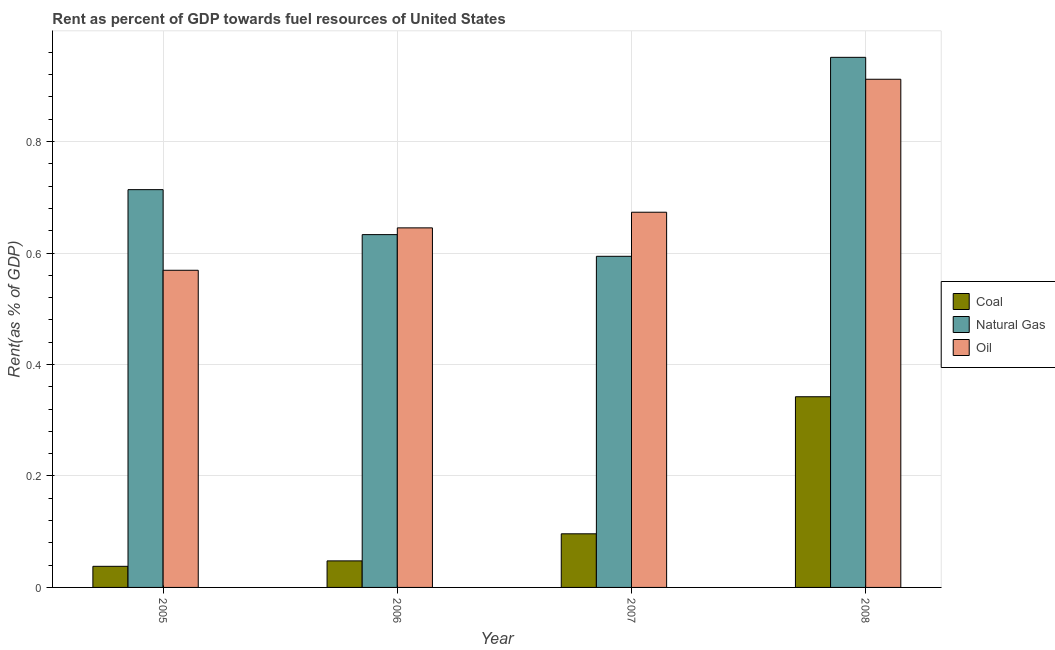Are the number of bars on each tick of the X-axis equal?
Make the answer very short. Yes. How many bars are there on the 1st tick from the left?
Give a very brief answer. 3. In how many cases, is the number of bars for a given year not equal to the number of legend labels?
Your answer should be compact. 0. What is the rent towards natural gas in 2007?
Your answer should be very brief. 0.59. Across all years, what is the maximum rent towards natural gas?
Ensure brevity in your answer.  0.95. Across all years, what is the minimum rent towards natural gas?
Provide a succinct answer. 0.59. In which year was the rent towards natural gas maximum?
Ensure brevity in your answer.  2008. What is the total rent towards natural gas in the graph?
Offer a terse response. 2.89. What is the difference between the rent towards coal in 2006 and that in 2007?
Ensure brevity in your answer.  -0.05. What is the difference between the rent towards oil in 2007 and the rent towards coal in 2006?
Your answer should be compact. 0.03. What is the average rent towards coal per year?
Your response must be concise. 0.13. In how many years, is the rent towards natural gas greater than 0.68 %?
Your response must be concise. 2. What is the ratio of the rent towards oil in 2005 to that in 2006?
Your answer should be compact. 0.88. What is the difference between the highest and the second highest rent towards coal?
Provide a short and direct response. 0.25. What is the difference between the highest and the lowest rent towards natural gas?
Provide a succinct answer. 0.36. In how many years, is the rent towards coal greater than the average rent towards coal taken over all years?
Your answer should be very brief. 1. Is the sum of the rent towards oil in 2005 and 2007 greater than the maximum rent towards natural gas across all years?
Your answer should be compact. Yes. What does the 1st bar from the left in 2006 represents?
Offer a very short reply. Coal. What does the 1st bar from the right in 2006 represents?
Your response must be concise. Oil. How many bars are there?
Provide a succinct answer. 12. Are all the bars in the graph horizontal?
Make the answer very short. No. What is the difference between two consecutive major ticks on the Y-axis?
Make the answer very short. 0.2. How are the legend labels stacked?
Keep it short and to the point. Vertical. What is the title of the graph?
Give a very brief answer. Rent as percent of GDP towards fuel resources of United States. Does "Social Protection" appear as one of the legend labels in the graph?
Your answer should be very brief. No. What is the label or title of the Y-axis?
Provide a succinct answer. Rent(as % of GDP). What is the Rent(as % of GDP) in Coal in 2005?
Your response must be concise. 0.04. What is the Rent(as % of GDP) of Natural Gas in 2005?
Your response must be concise. 0.71. What is the Rent(as % of GDP) in Oil in 2005?
Ensure brevity in your answer.  0.57. What is the Rent(as % of GDP) in Coal in 2006?
Make the answer very short. 0.05. What is the Rent(as % of GDP) in Natural Gas in 2006?
Your response must be concise. 0.63. What is the Rent(as % of GDP) of Oil in 2006?
Make the answer very short. 0.65. What is the Rent(as % of GDP) of Coal in 2007?
Make the answer very short. 0.1. What is the Rent(as % of GDP) in Natural Gas in 2007?
Offer a very short reply. 0.59. What is the Rent(as % of GDP) in Oil in 2007?
Provide a short and direct response. 0.67. What is the Rent(as % of GDP) in Coal in 2008?
Offer a very short reply. 0.34. What is the Rent(as % of GDP) of Natural Gas in 2008?
Your response must be concise. 0.95. What is the Rent(as % of GDP) in Oil in 2008?
Ensure brevity in your answer.  0.91. Across all years, what is the maximum Rent(as % of GDP) of Coal?
Offer a very short reply. 0.34. Across all years, what is the maximum Rent(as % of GDP) of Natural Gas?
Your answer should be very brief. 0.95. Across all years, what is the maximum Rent(as % of GDP) of Oil?
Your response must be concise. 0.91. Across all years, what is the minimum Rent(as % of GDP) in Coal?
Offer a terse response. 0.04. Across all years, what is the minimum Rent(as % of GDP) in Natural Gas?
Your answer should be compact. 0.59. Across all years, what is the minimum Rent(as % of GDP) of Oil?
Offer a very short reply. 0.57. What is the total Rent(as % of GDP) of Coal in the graph?
Your answer should be compact. 0.52. What is the total Rent(as % of GDP) in Natural Gas in the graph?
Keep it short and to the point. 2.89. What is the total Rent(as % of GDP) in Oil in the graph?
Provide a short and direct response. 2.8. What is the difference between the Rent(as % of GDP) of Coal in 2005 and that in 2006?
Offer a terse response. -0.01. What is the difference between the Rent(as % of GDP) of Natural Gas in 2005 and that in 2006?
Your answer should be very brief. 0.08. What is the difference between the Rent(as % of GDP) of Oil in 2005 and that in 2006?
Ensure brevity in your answer.  -0.08. What is the difference between the Rent(as % of GDP) in Coal in 2005 and that in 2007?
Give a very brief answer. -0.06. What is the difference between the Rent(as % of GDP) of Natural Gas in 2005 and that in 2007?
Make the answer very short. 0.12. What is the difference between the Rent(as % of GDP) of Oil in 2005 and that in 2007?
Make the answer very short. -0.1. What is the difference between the Rent(as % of GDP) of Coal in 2005 and that in 2008?
Your answer should be compact. -0.3. What is the difference between the Rent(as % of GDP) of Natural Gas in 2005 and that in 2008?
Your answer should be very brief. -0.24. What is the difference between the Rent(as % of GDP) in Oil in 2005 and that in 2008?
Offer a terse response. -0.34. What is the difference between the Rent(as % of GDP) of Coal in 2006 and that in 2007?
Make the answer very short. -0.05. What is the difference between the Rent(as % of GDP) in Natural Gas in 2006 and that in 2007?
Keep it short and to the point. 0.04. What is the difference between the Rent(as % of GDP) of Oil in 2006 and that in 2007?
Provide a succinct answer. -0.03. What is the difference between the Rent(as % of GDP) of Coal in 2006 and that in 2008?
Provide a succinct answer. -0.29. What is the difference between the Rent(as % of GDP) of Natural Gas in 2006 and that in 2008?
Offer a terse response. -0.32. What is the difference between the Rent(as % of GDP) of Oil in 2006 and that in 2008?
Your answer should be compact. -0.27. What is the difference between the Rent(as % of GDP) of Coal in 2007 and that in 2008?
Offer a very short reply. -0.25. What is the difference between the Rent(as % of GDP) of Natural Gas in 2007 and that in 2008?
Your answer should be very brief. -0.36. What is the difference between the Rent(as % of GDP) in Oil in 2007 and that in 2008?
Keep it short and to the point. -0.24. What is the difference between the Rent(as % of GDP) of Coal in 2005 and the Rent(as % of GDP) of Natural Gas in 2006?
Offer a terse response. -0.6. What is the difference between the Rent(as % of GDP) in Coal in 2005 and the Rent(as % of GDP) in Oil in 2006?
Provide a succinct answer. -0.61. What is the difference between the Rent(as % of GDP) in Natural Gas in 2005 and the Rent(as % of GDP) in Oil in 2006?
Keep it short and to the point. 0.07. What is the difference between the Rent(as % of GDP) of Coal in 2005 and the Rent(as % of GDP) of Natural Gas in 2007?
Ensure brevity in your answer.  -0.56. What is the difference between the Rent(as % of GDP) in Coal in 2005 and the Rent(as % of GDP) in Oil in 2007?
Offer a very short reply. -0.64. What is the difference between the Rent(as % of GDP) of Natural Gas in 2005 and the Rent(as % of GDP) of Oil in 2007?
Your answer should be compact. 0.04. What is the difference between the Rent(as % of GDP) in Coal in 2005 and the Rent(as % of GDP) in Natural Gas in 2008?
Ensure brevity in your answer.  -0.91. What is the difference between the Rent(as % of GDP) of Coal in 2005 and the Rent(as % of GDP) of Oil in 2008?
Your answer should be compact. -0.87. What is the difference between the Rent(as % of GDP) in Natural Gas in 2005 and the Rent(as % of GDP) in Oil in 2008?
Make the answer very short. -0.2. What is the difference between the Rent(as % of GDP) of Coal in 2006 and the Rent(as % of GDP) of Natural Gas in 2007?
Your answer should be compact. -0.55. What is the difference between the Rent(as % of GDP) in Coal in 2006 and the Rent(as % of GDP) in Oil in 2007?
Your answer should be compact. -0.63. What is the difference between the Rent(as % of GDP) of Natural Gas in 2006 and the Rent(as % of GDP) of Oil in 2007?
Give a very brief answer. -0.04. What is the difference between the Rent(as % of GDP) in Coal in 2006 and the Rent(as % of GDP) in Natural Gas in 2008?
Your answer should be compact. -0.9. What is the difference between the Rent(as % of GDP) of Coal in 2006 and the Rent(as % of GDP) of Oil in 2008?
Make the answer very short. -0.86. What is the difference between the Rent(as % of GDP) of Natural Gas in 2006 and the Rent(as % of GDP) of Oil in 2008?
Offer a very short reply. -0.28. What is the difference between the Rent(as % of GDP) of Coal in 2007 and the Rent(as % of GDP) of Natural Gas in 2008?
Give a very brief answer. -0.85. What is the difference between the Rent(as % of GDP) of Coal in 2007 and the Rent(as % of GDP) of Oil in 2008?
Your answer should be very brief. -0.82. What is the difference between the Rent(as % of GDP) of Natural Gas in 2007 and the Rent(as % of GDP) of Oil in 2008?
Your answer should be very brief. -0.32. What is the average Rent(as % of GDP) in Coal per year?
Keep it short and to the point. 0.13. What is the average Rent(as % of GDP) of Natural Gas per year?
Make the answer very short. 0.72. What is the average Rent(as % of GDP) of Oil per year?
Provide a short and direct response. 0.7. In the year 2005, what is the difference between the Rent(as % of GDP) of Coal and Rent(as % of GDP) of Natural Gas?
Provide a succinct answer. -0.68. In the year 2005, what is the difference between the Rent(as % of GDP) in Coal and Rent(as % of GDP) in Oil?
Provide a short and direct response. -0.53. In the year 2005, what is the difference between the Rent(as % of GDP) of Natural Gas and Rent(as % of GDP) of Oil?
Your answer should be compact. 0.14. In the year 2006, what is the difference between the Rent(as % of GDP) of Coal and Rent(as % of GDP) of Natural Gas?
Ensure brevity in your answer.  -0.59. In the year 2006, what is the difference between the Rent(as % of GDP) of Coal and Rent(as % of GDP) of Oil?
Your answer should be compact. -0.6. In the year 2006, what is the difference between the Rent(as % of GDP) in Natural Gas and Rent(as % of GDP) in Oil?
Keep it short and to the point. -0.01. In the year 2007, what is the difference between the Rent(as % of GDP) of Coal and Rent(as % of GDP) of Natural Gas?
Ensure brevity in your answer.  -0.5. In the year 2007, what is the difference between the Rent(as % of GDP) in Coal and Rent(as % of GDP) in Oil?
Offer a terse response. -0.58. In the year 2007, what is the difference between the Rent(as % of GDP) of Natural Gas and Rent(as % of GDP) of Oil?
Provide a succinct answer. -0.08. In the year 2008, what is the difference between the Rent(as % of GDP) in Coal and Rent(as % of GDP) in Natural Gas?
Keep it short and to the point. -0.61. In the year 2008, what is the difference between the Rent(as % of GDP) in Coal and Rent(as % of GDP) in Oil?
Give a very brief answer. -0.57. In the year 2008, what is the difference between the Rent(as % of GDP) of Natural Gas and Rent(as % of GDP) of Oil?
Ensure brevity in your answer.  0.04. What is the ratio of the Rent(as % of GDP) in Coal in 2005 to that in 2006?
Your response must be concise. 0.8. What is the ratio of the Rent(as % of GDP) in Natural Gas in 2005 to that in 2006?
Offer a terse response. 1.13. What is the ratio of the Rent(as % of GDP) in Oil in 2005 to that in 2006?
Keep it short and to the point. 0.88. What is the ratio of the Rent(as % of GDP) of Coal in 2005 to that in 2007?
Offer a very short reply. 0.39. What is the ratio of the Rent(as % of GDP) of Natural Gas in 2005 to that in 2007?
Offer a very short reply. 1.2. What is the ratio of the Rent(as % of GDP) in Oil in 2005 to that in 2007?
Keep it short and to the point. 0.85. What is the ratio of the Rent(as % of GDP) in Coal in 2005 to that in 2008?
Your answer should be very brief. 0.11. What is the ratio of the Rent(as % of GDP) in Natural Gas in 2005 to that in 2008?
Offer a very short reply. 0.75. What is the ratio of the Rent(as % of GDP) in Oil in 2005 to that in 2008?
Keep it short and to the point. 0.62. What is the ratio of the Rent(as % of GDP) of Coal in 2006 to that in 2007?
Provide a short and direct response. 0.49. What is the ratio of the Rent(as % of GDP) of Natural Gas in 2006 to that in 2007?
Your response must be concise. 1.07. What is the ratio of the Rent(as % of GDP) of Oil in 2006 to that in 2007?
Give a very brief answer. 0.96. What is the ratio of the Rent(as % of GDP) in Coal in 2006 to that in 2008?
Your answer should be very brief. 0.14. What is the ratio of the Rent(as % of GDP) in Natural Gas in 2006 to that in 2008?
Ensure brevity in your answer.  0.67. What is the ratio of the Rent(as % of GDP) in Oil in 2006 to that in 2008?
Your answer should be compact. 0.71. What is the ratio of the Rent(as % of GDP) of Coal in 2007 to that in 2008?
Your answer should be compact. 0.28. What is the ratio of the Rent(as % of GDP) in Natural Gas in 2007 to that in 2008?
Your response must be concise. 0.62. What is the ratio of the Rent(as % of GDP) of Oil in 2007 to that in 2008?
Offer a terse response. 0.74. What is the difference between the highest and the second highest Rent(as % of GDP) of Coal?
Provide a succinct answer. 0.25. What is the difference between the highest and the second highest Rent(as % of GDP) of Natural Gas?
Offer a very short reply. 0.24. What is the difference between the highest and the second highest Rent(as % of GDP) of Oil?
Offer a very short reply. 0.24. What is the difference between the highest and the lowest Rent(as % of GDP) of Coal?
Give a very brief answer. 0.3. What is the difference between the highest and the lowest Rent(as % of GDP) in Natural Gas?
Give a very brief answer. 0.36. What is the difference between the highest and the lowest Rent(as % of GDP) in Oil?
Provide a succinct answer. 0.34. 